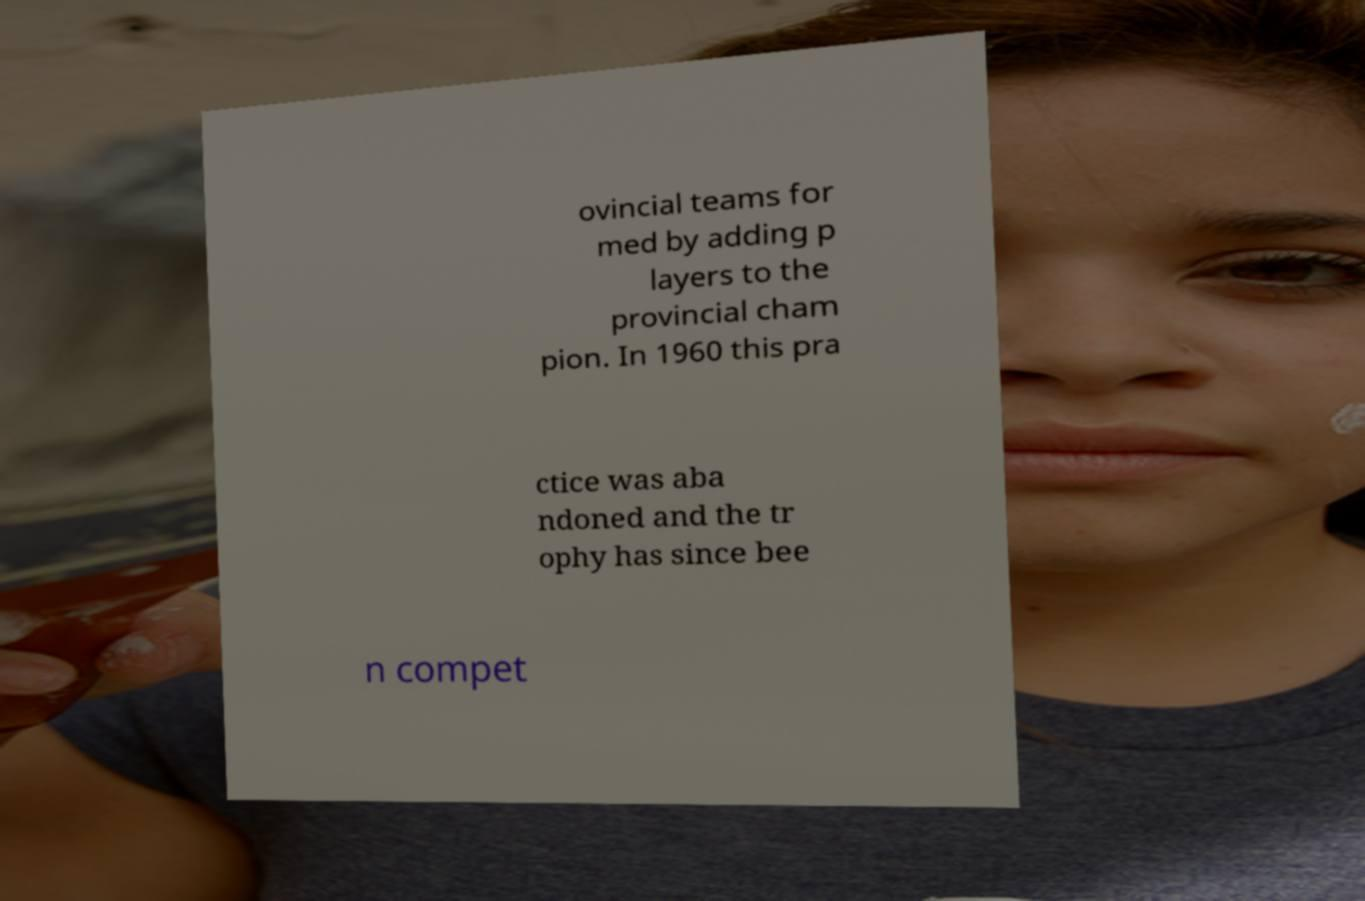Please identify and transcribe the text found in this image. ovincial teams for med by adding p layers to the provincial cham pion. In 1960 this pra ctice was aba ndoned and the tr ophy has since bee n compet 